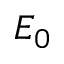<formula> <loc_0><loc_0><loc_500><loc_500>E _ { 0 }</formula> 